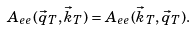Convert formula to latex. <formula><loc_0><loc_0><loc_500><loc_500>A _ { e e } ( \vec { q } _ { T } , \vec { k } _ { T } ) = A _ { e e } ( \vec { k } _ { T } , \vec { q } _ { T } ) .</formula> 